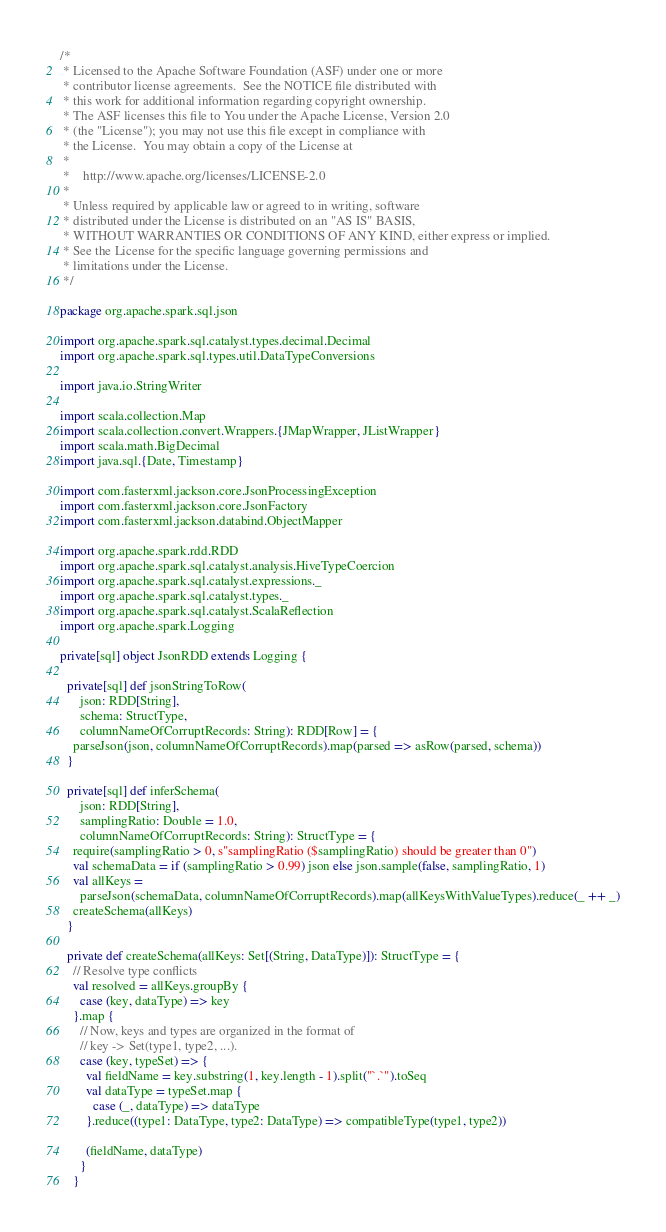Convert code to text. <code><loc_0><loc_0><loc_500><loc_500><_Scala_>/*
 * Licensed to the Apache Software Foundation (ASF) under one or more
 * contributor license agreements.  See the NOTICE file distributed with
 * this work for additional information regarding copyright ownership.
 * The ASF licenses this file to You under the Apache License, Version 2.0
 * (the "License"); you may not use this file except in compliance with
 * the License.  You may obtain a copy of the License at
 *
 *    http://www.apache.org/licenses/LICENSE-2.0
 *
 * Unless required by applicable law or agreed to in writing, software
 * distributed under the License is distributed on an "AS IS" BASIS,
 * WITHOUT WARRANTIES OR CONDITIONS OF ANY KIND, either express or implied.
 * See the License for the specific language governing permissions and
 * limitations under the License.
 */

package org.apache.spark.sql.json

import org.apache.spark.sql.catalyst.types.decimal.Decimal
import org.apache.spark.sql.types.util.DataTypeConversions

import java.io.StringWriter

import scala.collection.Map
import scala.collection.convert.Wrappers.{JMapWrapper, JListWrapper}
import scala.math.BigDecimal
import java.sql.{Date, Timestamp}

import com.fasterxml.jackson.core.JsonProcessingException
import com.fasterxml.jackson.core.JsonFactory
import com.fasterxml.jackson.databind.ObjectMapper

import org.apache.spark.rdd.RDD
import org.apache.spark.sql.catalyst.analysis.HiveTypeCoercion
import org.apache.spark.sql.catalyst.expressions._
import org.apache.spark.sql.catalyst.types._
import org.apache.spark.sql.catalyst.ScalaReflection
import org.apache.spark.Logging

private[sql] object JsonRDD extends Logging {

  private[sql] def jsonStringToRow(
      json: RDD[String],
      schema: StructType,
      columnNameOfCorruptRecords: String): RDD[Row] = {
    parseJson(json, columnNameOfCorruptRecords).map(parsed => asRow(parsed, schema))
  }

  private[sql] def inferSchema(
      json: RDD[String],
      samplingRatio: Double = 1.0,
      columnNameOfCorruptRecords: String): StructType = {
    require(samplingRatio > 0, s"samplingRatio ($samplingRatio) should be greater than 0")
    val schemaData = if (samplingRatio > 0.99) json else json.sample(false, samplingRatio, 1)
    val allKeys =
      parseJson(schemaData, columnNameOfCorruptRecords).map(allKeysWithValueTypes).reduce(_ ++ _)
    createSchema(allKeys)
  }

  private def createSchema(allKeys: Set[(String, DataType)]): StructType = {
    // Resolve type conflicts
    val resolved = allKeys.groupBy {
      case (key, dataType) => key
    }.map {
      // Now, keys and types are organized in the format of
      // key -> Set(type1, type2, ...).
      case (key, typeSet) => {
        val fieldName = key.substring(1, key.length - 1).split("`.`").toSeq
        val dataType = typeSet.map {
          case (_, dataType) => dataType
        }.reduce((type1: DataType, type2: DataType) => compatibleType(type1, type2))

        (fieldName, dataType)
      }
    }
</code> 